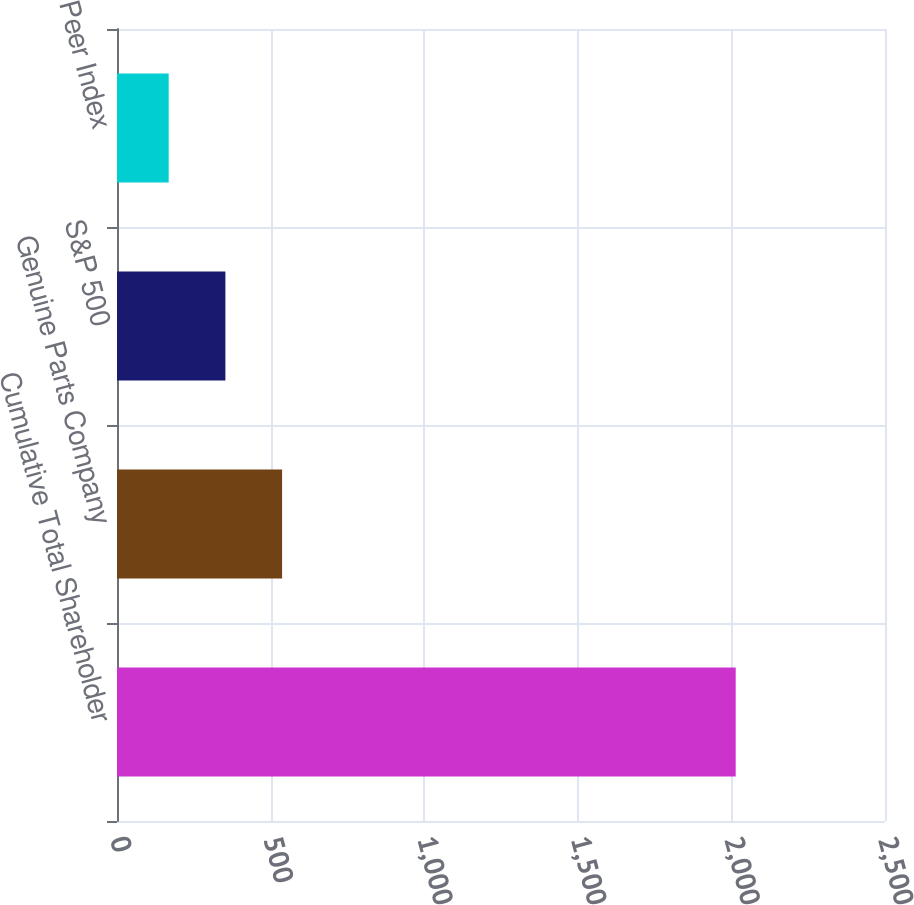Convert chart. <chart><loc_0><loc_0><loc_500><loc_500><bar_chart><fcel>Cumulative Total Shareholder<fcel>Genuine Parts Company<fcel>S&P 500<fcel>Peer Index<nl><fcel>2014<fcel>537.4<fcel>352.83<fcel>168.26<nl></chart> 